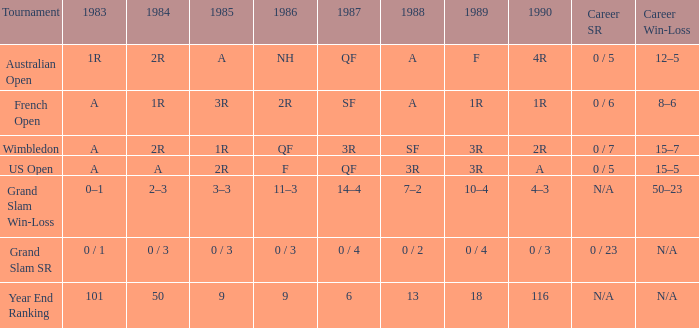What tournament has 0 / 5 as career SR and A as 1983? US Open. 